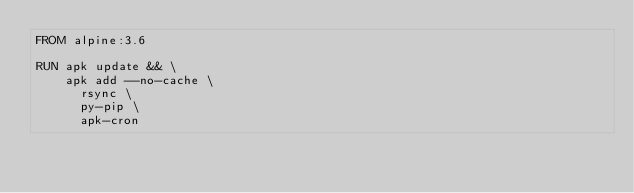Convert code to text. <code><loc_0><loc_0><loc_500><loc_500><_Dockerfile_>FROM alpine:3.6

RUN apk update && \
    apk add --no-cache \
      rsync \
      py-pip \
      apk-cron
</code> 